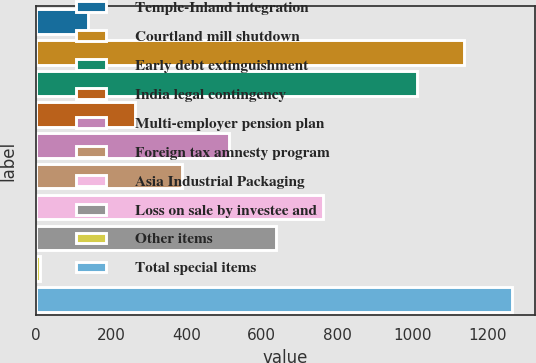Convert chart to OTSL. <chart><loc_0><loc_0><loc_500><loc_500><bar_chart><fcel>Temple-Inland integration<fcel>Courtland mill shutdown<fcel>Early debt extinguishment<fcel>India legal contingency<fcel>Multi-employer pension plan<fcel>Foreign tax amnesty program<fcel>Asia Industrial Packaging<fcel>Loss on sale by investee and<fcel>Other items<fcel>Total special items<nl><fcel>137.2<fcel>1138.8<fcel>1013.6<fcel>262.4<fcel>512.8<fcel>387.6<fcel>763.2<fcel>638<fcel>12<fcel>1264<nl></chart> 